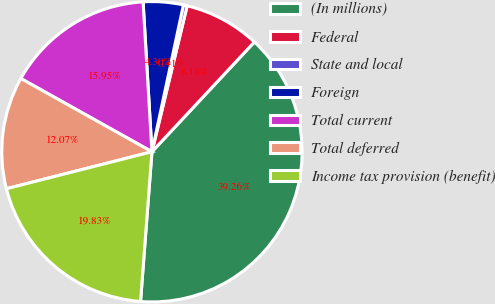Convert chart to OTSL. <chart><loc_0><loc_0><loc_500><loc_500><pie_chart><fcel>(In millions)<fcel>Federal<fcel>State and local<fcel>Foreign<fcel>Total current<fcel>Total deferred<fcel>Income tax provision (benefit)<nl><fcel>39.26%<fcel>8.18%<fcel>0.41%<fcel>4.3%<fcel>15.95%<fcel>12.07%<fcel>19.83%<nl></chart> 